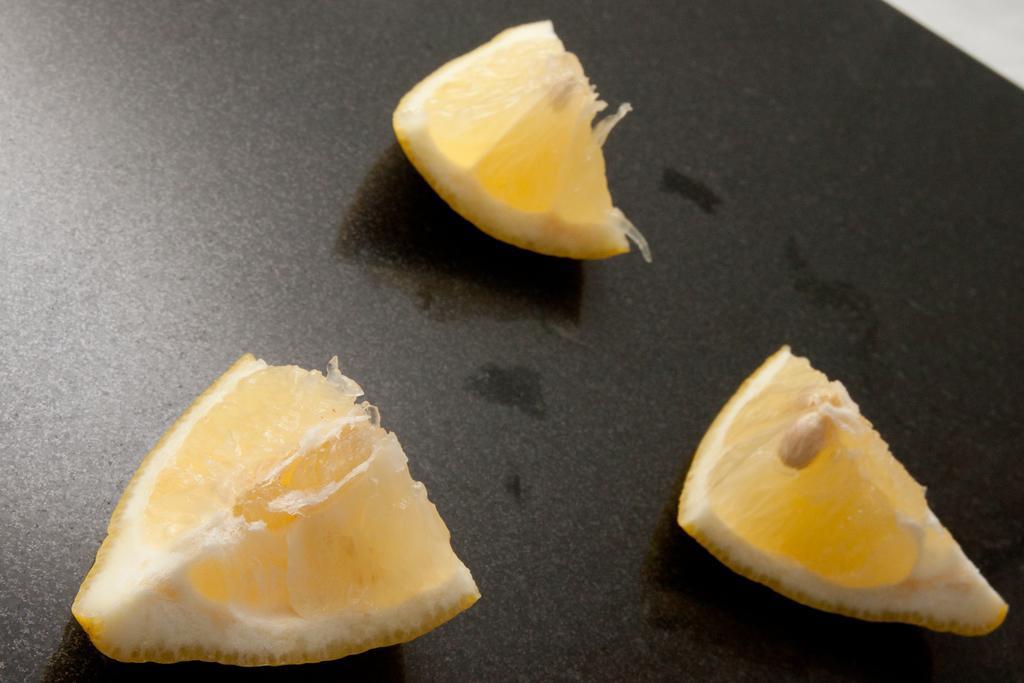Can you describe this image briefly? In this picture I can see there are three pieces of lemon placed on a black surface and the lemon pieces on to right have seeds. 